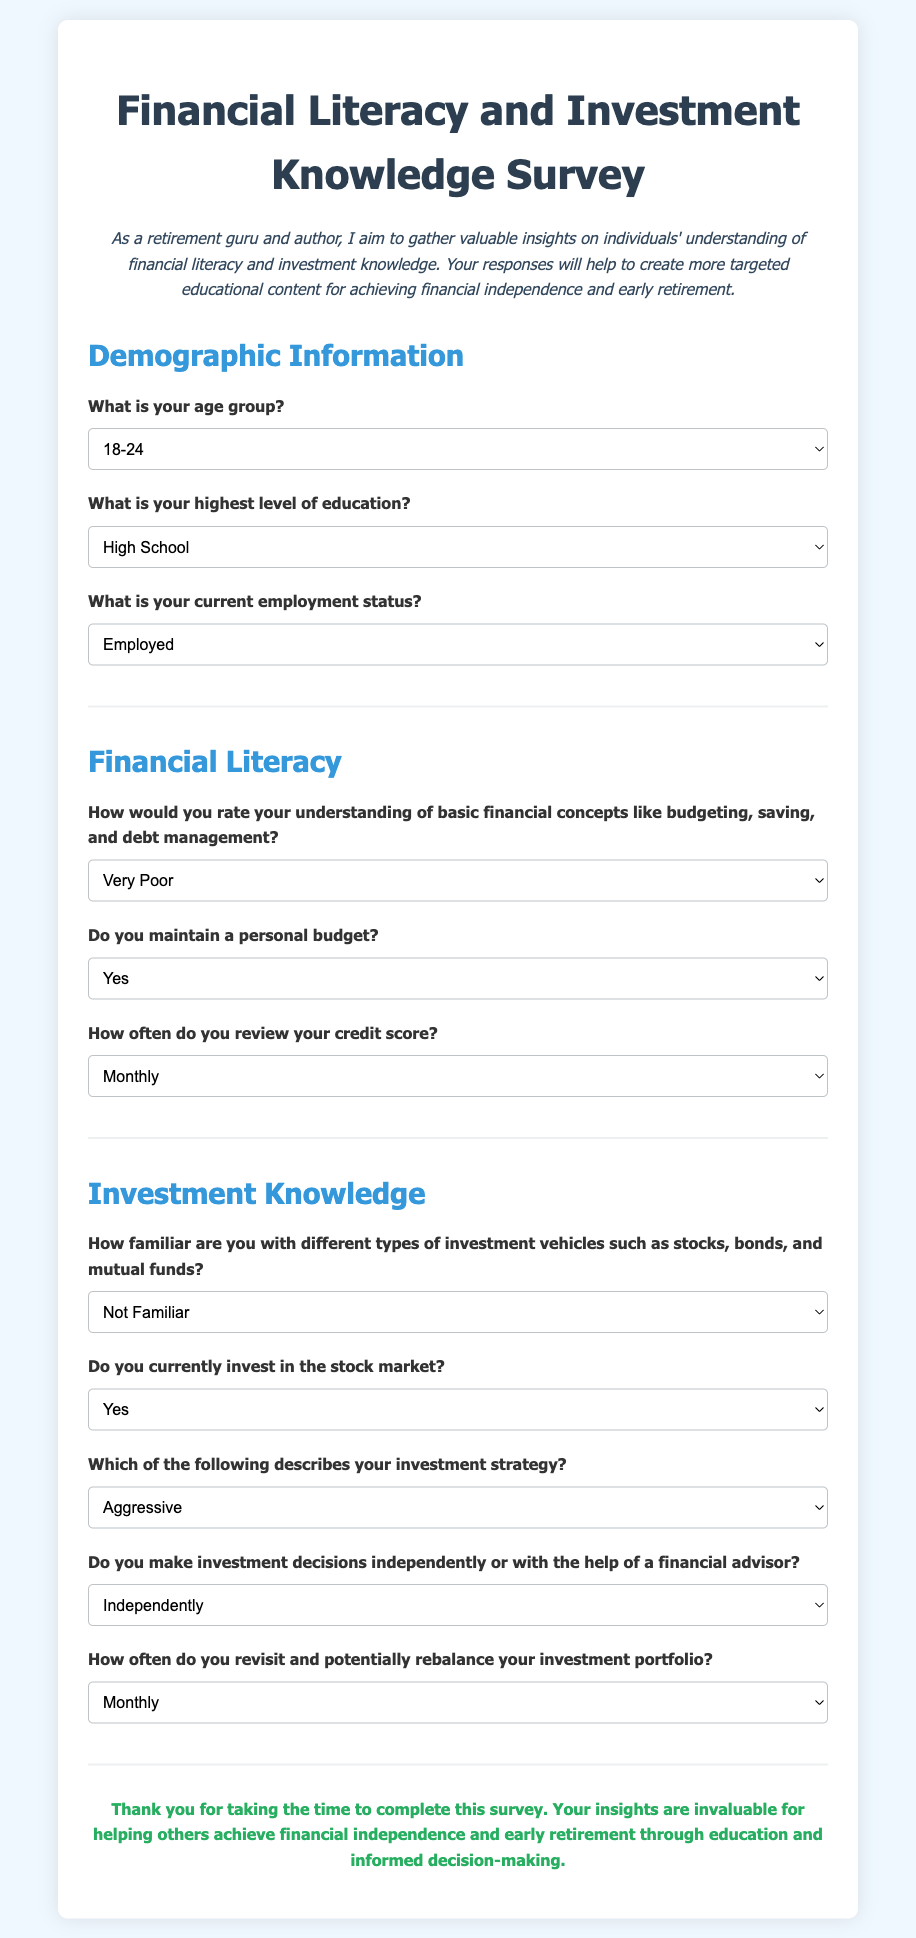What is the title of the survey? The title of the survey is prominently displayed at the top of the document.
Answer: Financial Literacy and Investment Knowledge Survey What age group has the option "65+"? The "65+" age group is one of the choices available in the demographic information section.
Answer: 65+ How often can participants select to review their credit score? The options available for reviewing the credit score describe different frequencies from the choices.
Answer: Monthly, Quarterly, Annually, Never What is the highest level of education option available? The highest level of education choice available is the last option in the list.
Answer: Doctorate What is the purpose of gathering insights from the survey? The purpose is mentioned in the introductory paragraph of the document.
Answer: To create targeted educational content How many investment strategies are listed in the survey? The number of investment strategies is determined by counting the options in the investment strategy question.
Answer: Four What type of survey is this document? The type of survey is evident from the overall structure and intended content of the document.
Answer: Financial literacy survey What is the option for those who do not invest? The choice specifically represents individuals who are not currently investing.
Answer: Do Not Invest How are respondents thanked in the document? The document concludes with a specific expression of gratitude towards the respondents.
Answer: Thank you for taking the time to complete this survey 